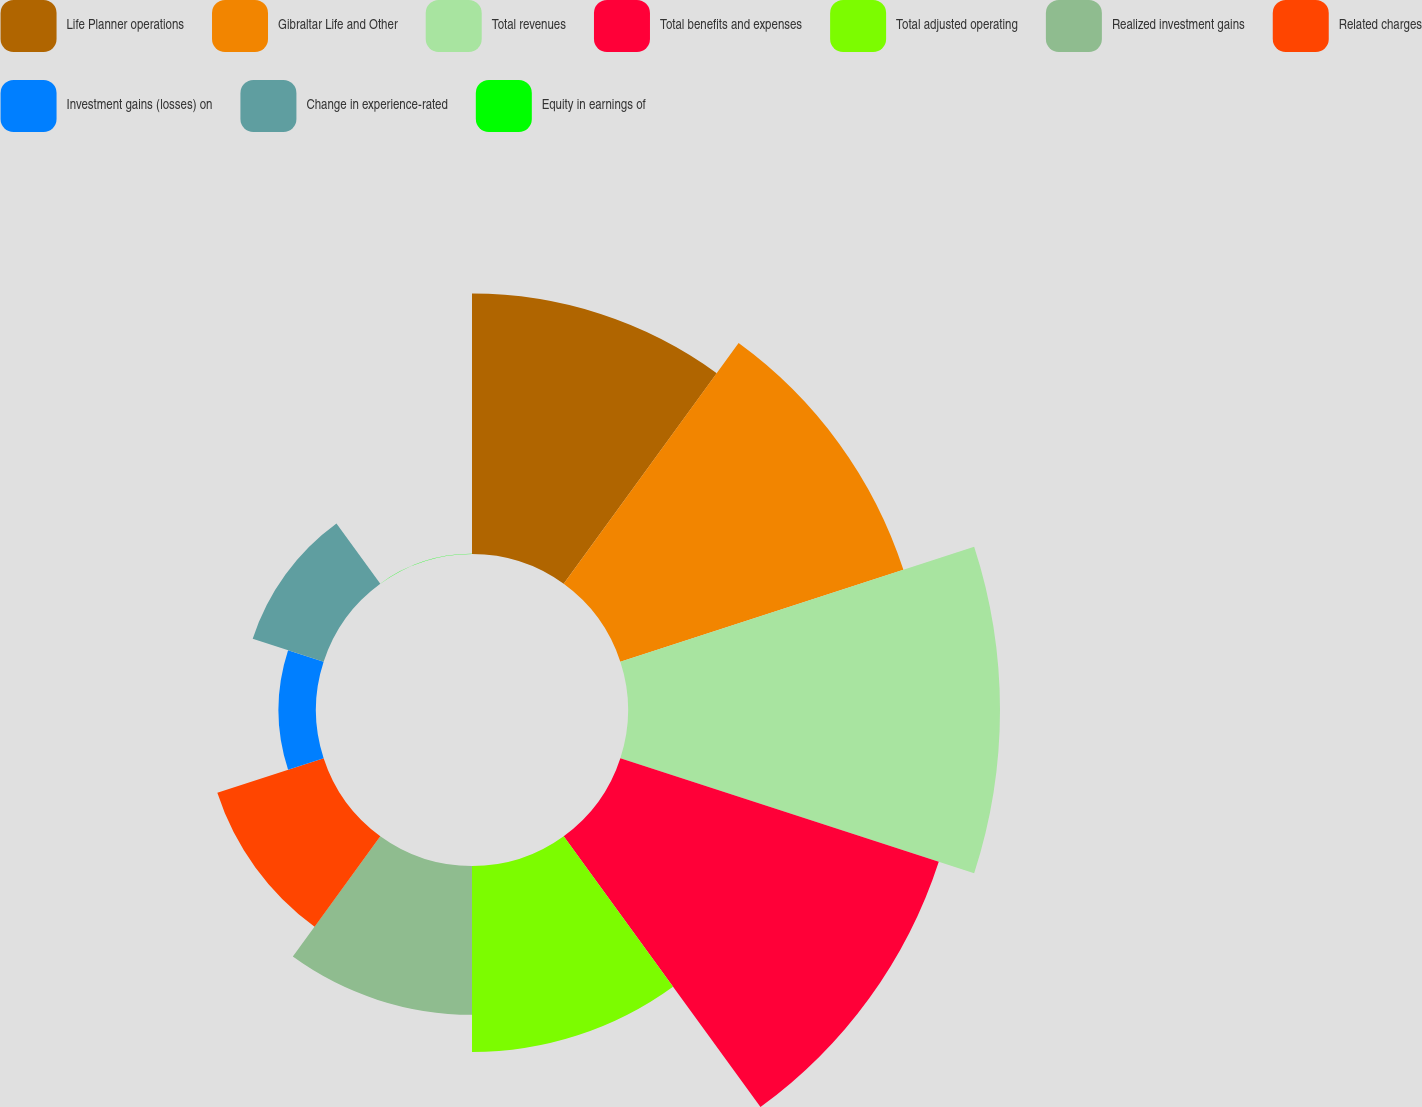<chart> <loc_0><loc_0><loc_500><loc_500><pie_chart><fcel>Life Planner operations<fcel>Gibraltar Life and Other<fcel>Total revenues<fcel>Total benefits and expenses<fcel>Total adjusted operating<fcel>Realized investment gains<fcel>Related charges<fcel>Investment gains (losses) on<fcel>Change in experience-rated<fcel>Equity in earnings of<nl><fcel>14.28%<fcel>16.32%<fcel>20.4%<fcel>18.36%<fcel>10.2%<fcel>8.16%<fcel>6.13%<fcel>2.05%<fcel>4.09%<fcel>0.01%<nl></chart> 